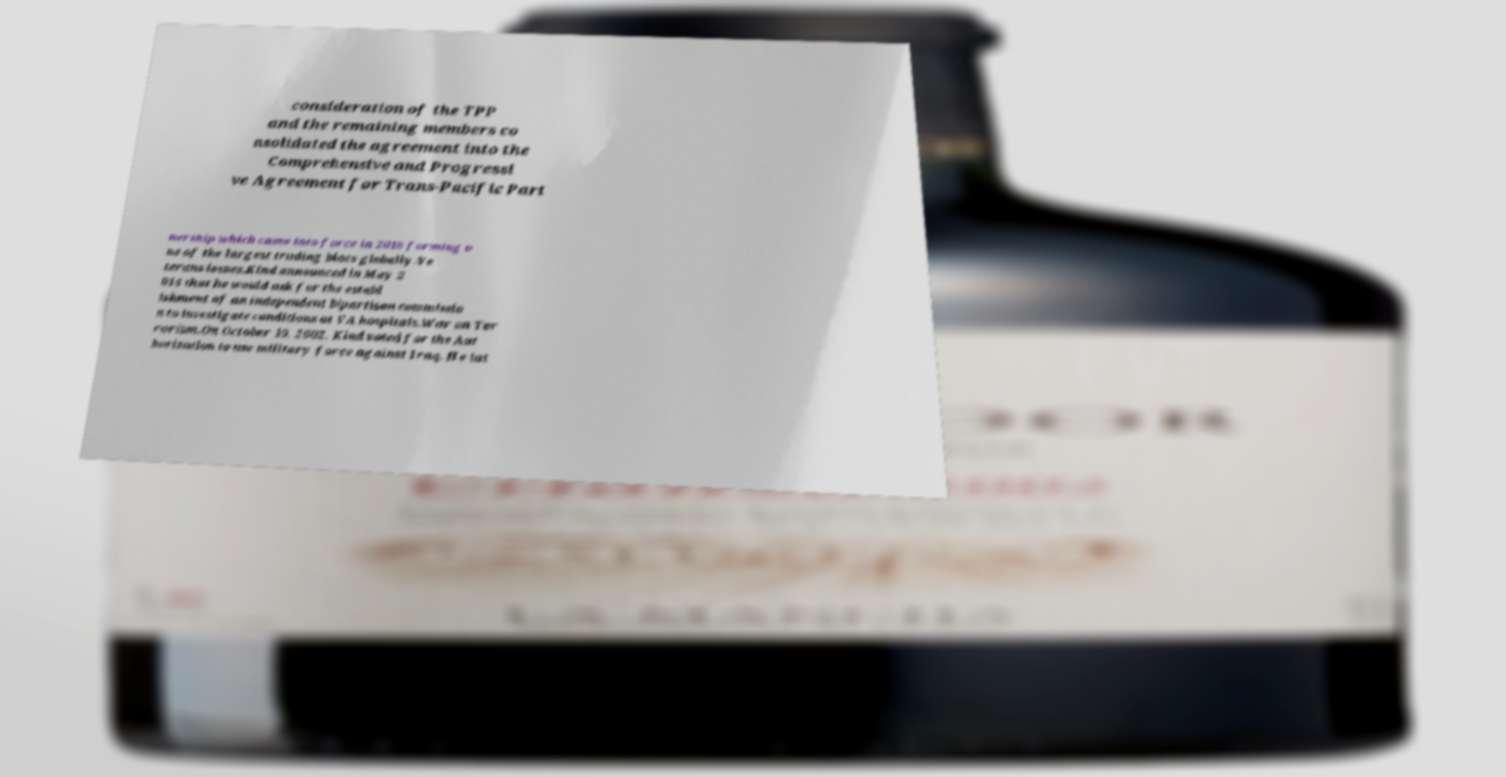Can you read and provide the text displayed in the image?This photo seems to have some interesting text. Can you extract and type it out for me? consideration of the TPP and the remaining members co nsolidated the agreement into the Comprehensive and Progressi ve Agreement for Trans-Pacific Part nership which came into force in 2018 forming o ne of the largest trading blocs globally.Ve terans issues.Kind announced in May 2 014 that he would ask for the establ ishment of an independent bipartisan commissio n to investigate conditions at VA hospitals.War on Ter rorism.On October 10, 2002, Kind voted for the Aut horization to use military force against Iraq. He lat 